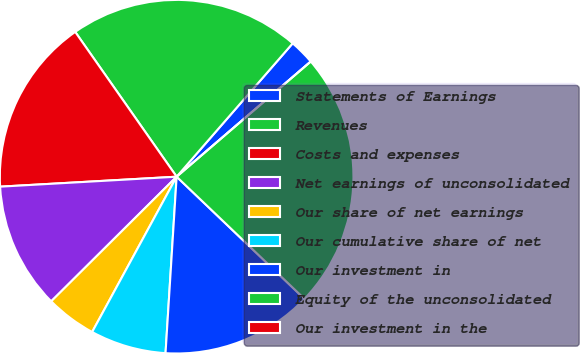Convert chart to OTSL. <chart><loc_0><loc_0><loc_500><loc_500><pie_chart><fcel>Statements of Earnings<fcel>Revenues<fcel>Costs and expenses<fcel>Net earnings of unconsolidated<fcel>Our share of net earnings<fcel>Our cumulative share of net<fcel>Our investment in<fcel>Equity of the unconsolidated<fcel>Our investment in the<nl><fcel>2.31%<fcel>21.12%<fcel>16.17%<fcel>11.55%<fcel>4.62%<fcel>6.93%<fcel>13.86%<fcel>23.43%<fcel>0.0%<nl></chart> 